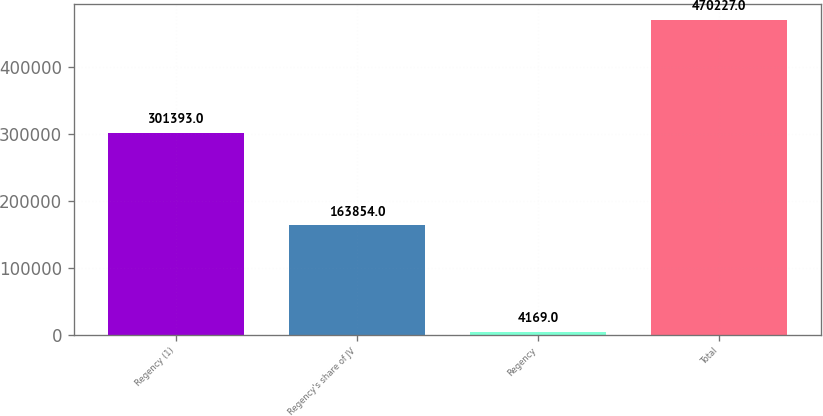Convert chart to OTSL. <chart><loc_0><loc_0><loc_500><loc_500><bar_chart><fcel>Regency (1)<fcel>Regency's share of JV<fcel>Regency<fcel>Total<nl><fcel>301393<fcel>163854<fcel>4169<fcel>470227<nl></chart> 